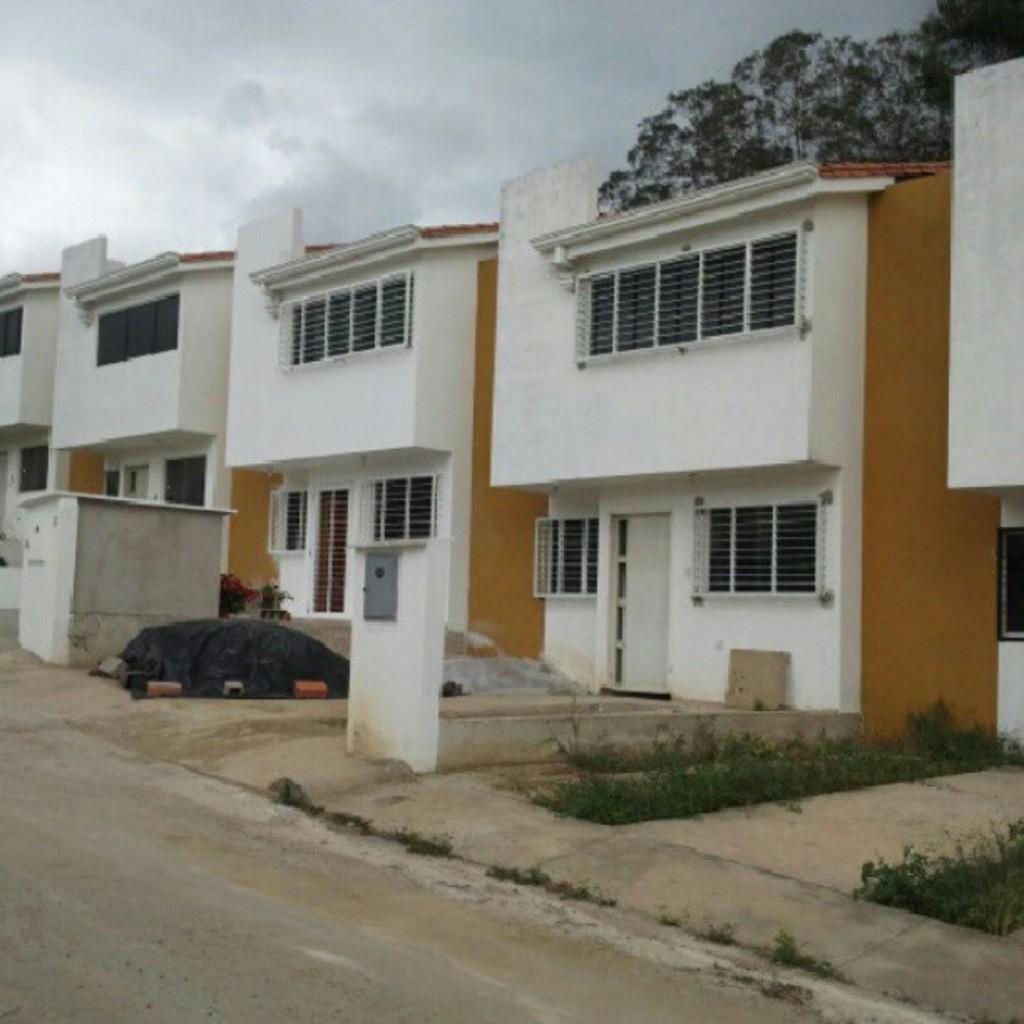Could you give a brief overview of what you see in this image? In this image, we can see a few houses with walls, door, windows, grills. Here we can see shed, pillars, plants, road. Background we can see a tree and sky. 